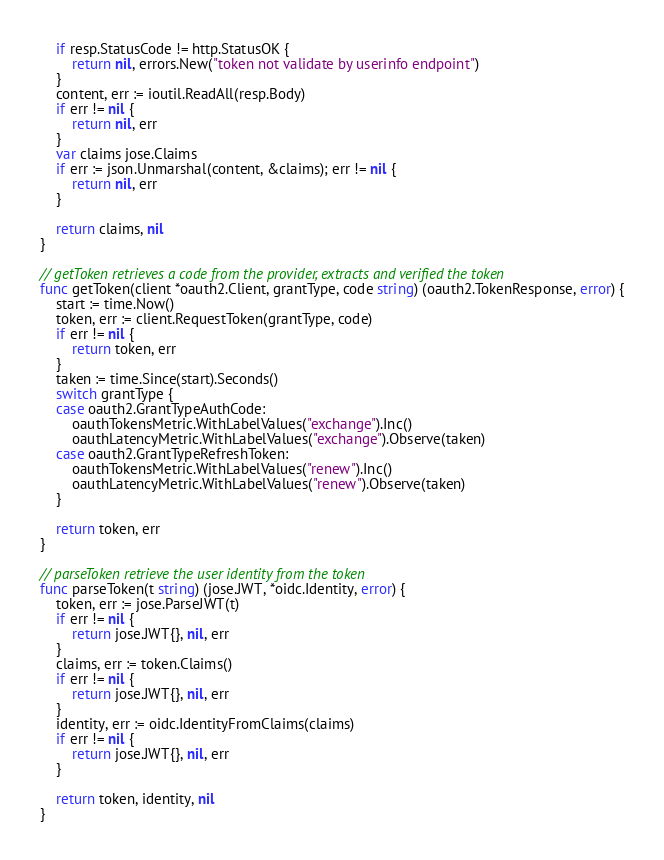<code> <loc_0><loc_0><loc_500><loc_500><_Go_>	if resp.StatusCode != http.StatusOK {
		return nil, errors.New("token not validate by userinfo endpoint")
	}
	content, err := ioutil.ReadAll(resp.Body)
	if err != nil {
		return nil, err
	}
	var claims jose.Claims
	if err := json.Unmarshal(content, &claims); err != nil {
		return nil, err
	}

	return claims, nil
}

// getToken retrieves a code from the provider, extracts and verified the token
func getToken(client *oauth2.Client, grantType, code string) (oauth2.TokenResponse, error) {
	start := time.Now()
	token, err := client.RequestToken(grantType, code)
	if err != nil {
		return token, err
	}
	taken := time.Since(start).Seconds()
	switch grantType {
	case oauth2.GrantTypeAuthCode:
		oauthTokensMetric.WithLabelValues("exchange").Inc()
		oauthLatencyMetric.WithLabelValues("exchange").Observe(taken)
	case oauth2.GrantTypeRefreshToken:
		oauthTokensMetric.WithLabelValues("renew").Inc()
		oauthLatencyMetric.WithLabelValues("renew").Observe(taken)
	}

	return token, err
}

// parseToken retrieve the user identity from the token
func parseToken(t string) (jose.JWT, *oidc.Identity, error) {
	token, err := jose.ParseJWT(t)
	if err != nil {
		return jose.JWT{}, nil, err
	}
	claims, err := token.Claims()
	if err != nil {
		return jose.JWT{}, nil, err
	}
	identity, err := oidc.IdentityFromClaims(claims)
	if err != nil {
		return jose.JWT{}, nil, err
	}

	return token, identity, nil
}
</code> 